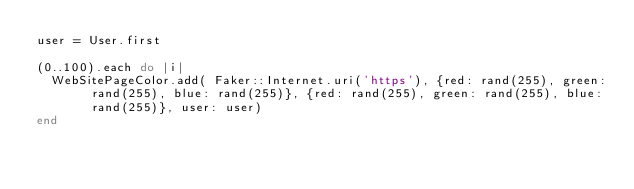Convert code to text. <code><loc_0><loc_0><loc_500><loc_500><_Ruby_>user = User.first

(0..100).each do |i|
  WebSitePageColor.add( Faker::Internet.uri('https'), {red: rand(255), green: rand(255), blue: rand(255)}, {red: rand(255), green: rand(255), blue: rand(255)}, user: user)
end
</code> 